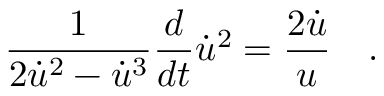Convert formula to latex. <formula><loc_0><loc_0><loc_500><loc_500>\frac { 1 } { 2 \dot { u } ^ { 2 } - \dot { u } ^ { 3 } } \frac { d } { d t } \dot { u } ^ { 2 } = \frac { 2 \dot { u } } { u } \quad .</formula> 